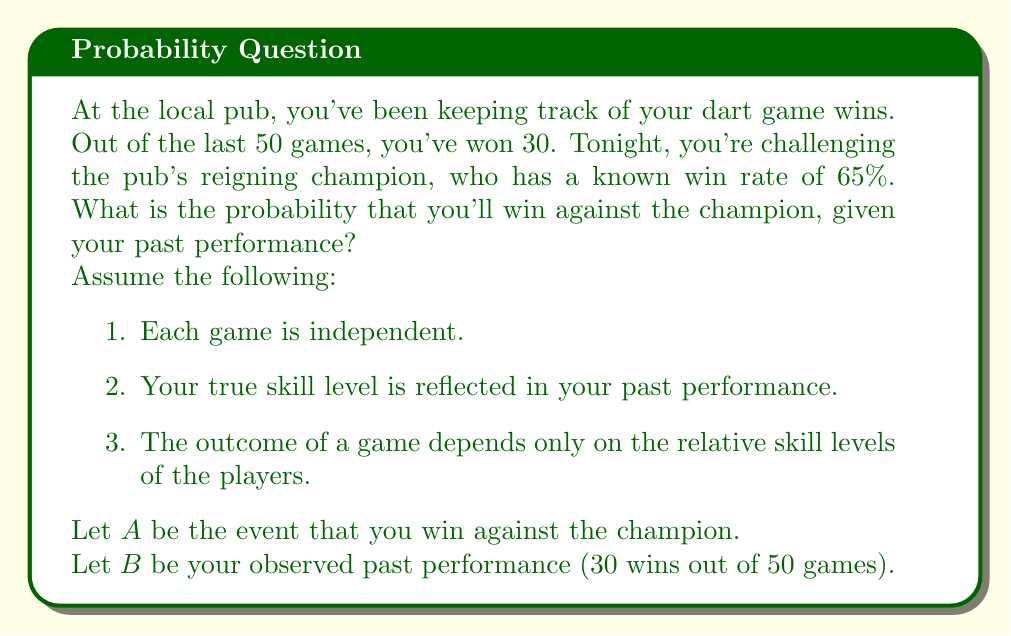Give your solution to this math problem. To solve this problem, we'll use Bayesian inference. We want to calculate $P(A|B)$, the probability of winning against the champion given our past performance.

Step 1: Calculate your win rate from past performance
Your win rate = $\frac{30}{50} = 0.6$ or 60%

Step 2: Use Bayes' theorem
$$P(A|B) = \frac{P(B|A) \cdot P(A)}{P(B)}$$

Step 3: Calculate $P(A)$, the prior probability of winning
Since the champion's win rate is 65%, your prior probability of winning is:
$P(A) = 1 - 0.65 = 0.35$

Step 4: Calculate $P(B|A)$, the likelihood
This is the probability of observing 30 wins out of 50 games, given that you can win against the champion. We can use the binomial distribution:
$$P(B|A) = \binom{50}{30} \cdot 0.6^{30} \cdot 0.4^{20}$$

Step 5: Calculate $P(B)$, the marginal likelihood
$P(B) = P(B|A) \cdot P(A) + P(B|\text{not }A) \cdot P(\text{not }A)$

$P(B|\text{not }A) = \binom{50}{30} \cdot 0.35^{30} \cdot 0.65^{20}$

$P(\text{not }A) = 0.65$

Step 6: Plug values into Bayes' theorem
$$P(A|B) = \frac{\binom{50}{30} \cdot 0.6^{30} \cdot 0.4^{20} \cdot 0.35}{\binom{50}{30} \cdot 0.6^{30} \cdot 0.4^{20} \cdot 0.35 + \binom{50}{30} \cdot 0.35^{30} \cdot 0.65^{20} \cdot 0.65}$$

Step 7: Simplify and calculate
After canceling out common factors and calculating, we get:
$$P(A|B) \approx 0.4286$$
Answer: $P(A|B) \approx 0.4286$ or about 42.86% 